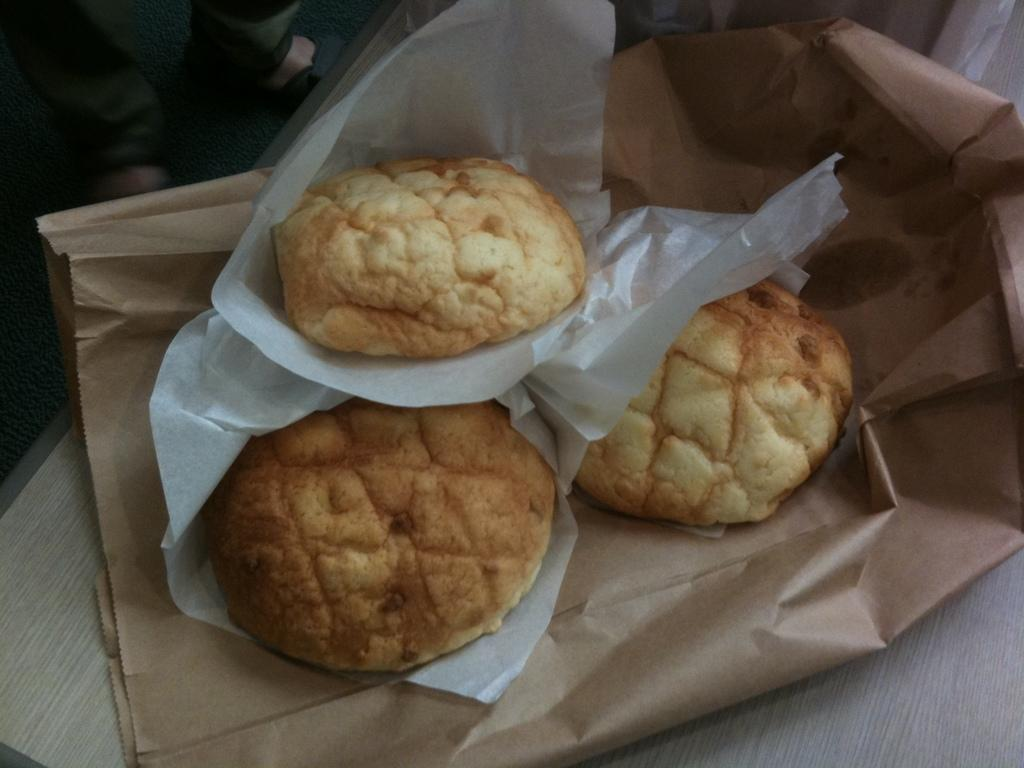What types of items can be seen in the image? There are food items and tissue visible in the image. What is the color of the cover in the image? The brown cover is present in the image. What can be seen in the background of the image? There is a surface visible in the background of the image. Where are the person's legs located in the image? The person's legs are visible on the left side top of the image. What type of flag is being waved by the person in the image? There is no flag visible in the image; only food items, tissue, a brown cover, a surface, and a person's legs are present. 